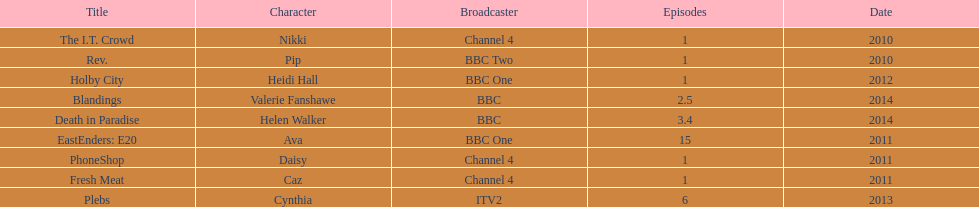What was the previous role this actress played before playing cynthia in plebs? Heidi Hall. 